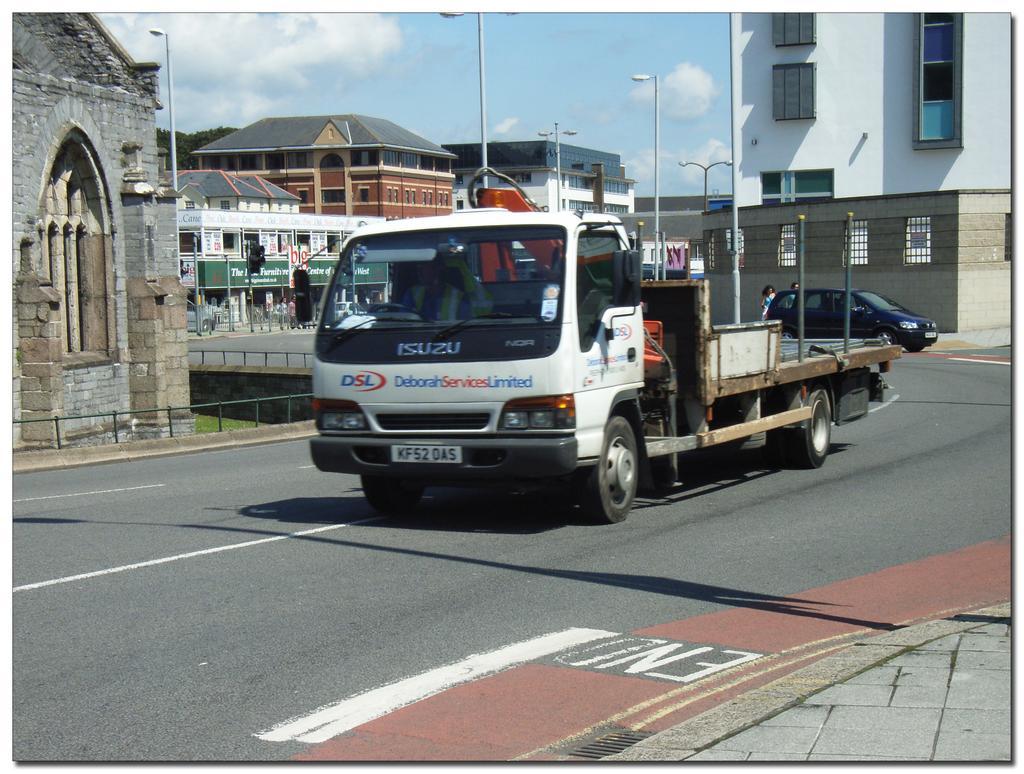Can you describe this image briefly? In this image I can see a road in the centre and on it I can see few vehicles. On the both side of the road I can see number of buildings, number of poles, street lights and people. In the background I can see few trees, clouds and the sky. I can also see a green colour board on the left side and on it I can see something is written. 